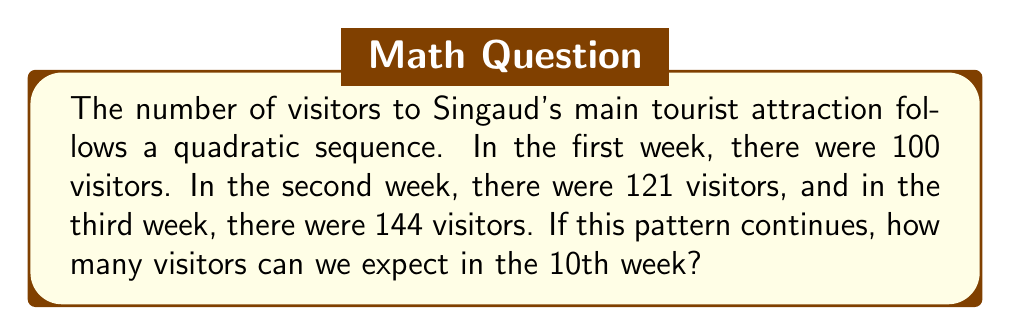Help me with this question. Let's approach this step-by-step:

1) First, we need to find the general term of the quadratic sequence. The general form of a quadratic sequence is:

   $a_n = an^2 + bn + c$

   where $n$ is the term number, and $a$, $b$, and $c$ are constants we need to determine.

2) We have three known terms:
   Week 1 (n=1): $a_1 = 100$
   Week 2 (n=2): $a_2 = 121$
   Week 3 (n=3): $a_3 = 144$

3) Substituting these into our general form:

   $100 = a(1)^2 + b(1) + c$
   $121 = a(2)^2 + b(2) + c$
   $144 = a(3)^2 + b(3) + c$

4) Simplifying:

   $100 = a + b + c$ ... (1)
   $121 = 4a + 2b + c$ ... (2)
   $144 = 9a + 3b + c$ ... (3)

5) Subtracting (1) from (2):
   $21 = 3a + b$ ... (4)

6) Subtracting (2) from (3):
   $23 = 5a + b$ ... (5)

7) Subtracting (4) from (5):
   $2 = 2a$
   $a = 1$

8) Substituting $a=1$ into (4):
   $21 = 3(1) + b$
   $b = 18$

9) Substituting $a=1$ and $b=18$ into (1):
   $100 = 1 + 18 + c$
   $c = 81$

10) Therefore, our quadratic sequence is:
    $a_n = n^2 + 18n + 81$

11) For the 10th week, $n = 10$:
    $a_{10} = 10^2 + 18(10) + 81$
    $= 100 + 180 + 81$
    $= 361$
Answer: 361 visitors 